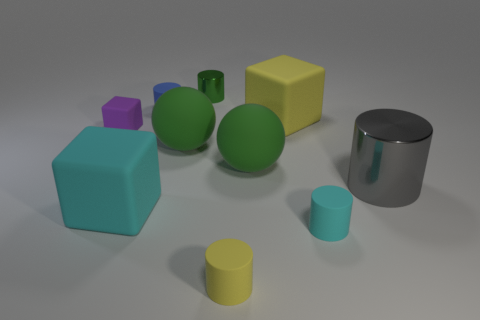Are there fewer large metallic cylinders than red metallic things?
Give a very brief answer. No. Is the size of the yellow block the same as the green sphere that is right of the small yellow rubber object?
Your answer should be compact. Yes. There is a metallic thing that is in front of the matte cylinder behind the tiny purple object; what color is it?
Offer a very short reply. Gray. How many objects are small objects behind the tiny purple object or big metallic cylinders in front of the small green thing?
Offer a terse response. 3. Do the green shiny cylinder and the purple rubber block have the same size?
Your response must be concise. Yes. Is there anything else that is the same size as the cyan cube?
Give a very brief answer. Yes. There is a tiny matte object on the right side of the yellow matte cube; is its shape the same as the matte thing that is behind the yellow rubber block?
Offer a terse response. Yes. What size is the cyan matte cylinder?
Provide a succinct answer. Small. There is a green object behind the yellow matte object that is behind the cyan object that is left of the blue matte cylinder; what is it made of?
Keep it short and to the point. Metal. What number of other things are there of the same color as the large metallic cylinder?
Keep it short and to the point. 0. 